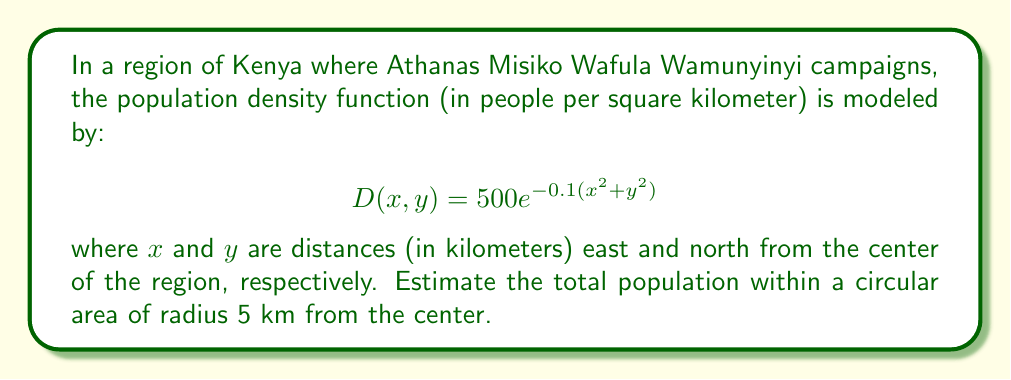Show me your answer to this math problem. To estimate the total population within the circular area, we need to integrate the population density function over the given region. This requires using multivariable calculus, specifically double integration in polar coordinates.

1) First, we need to set up the double integral:

   $$\text{Population} = \iint_R D(x,y) \, dA$$

   where $R$ is the circular region with radius 5 km.

2) Convert to polar coordinates:
   $x = r\cos\theta$, $y = r\sin\theta$
   $dA = r \, dr \, d\theta$

3) Rewrite the density function in polar coordinates:
   $$D(r,\theta) = 500e^{-0.1(r^2\cos^2\theta + r^2\sin^2\theta)} = 500e^{-0.1r^2}$$

4) Set up the double integral in polar coordinates:
   $$\text{Population} = \int_0^{2\pi} \int_0^5 500e^{-0.1r^2} \, r \, dr \, d\theta$$

5) Evaluate the inner integral:
   $$\int_0^{2\pi} \left[ -2500e^{-0.1r^2} \right]_0^5 \, d\theta$$
   $$= \int_0^{2\pi} \left( -2500e^{-2.5} + 2500 \right) \, d\theta$$

6) Evaluate the outer integral:
   $$= 2\pi \left( -2500e^{-2.5} + 2500 \right)$$

7) Calculate the final result:
   $$\approx 15,026.5$$

Therefore, the estimated population within the 5 km radius is approximately 15,027 people.
Answer: Approximately 15,027 people 